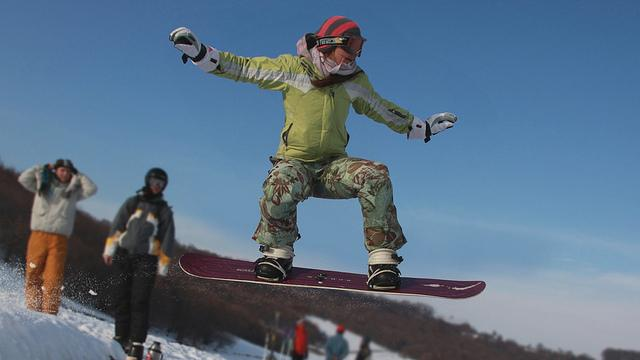Why are there straps on snowboards? support/response 